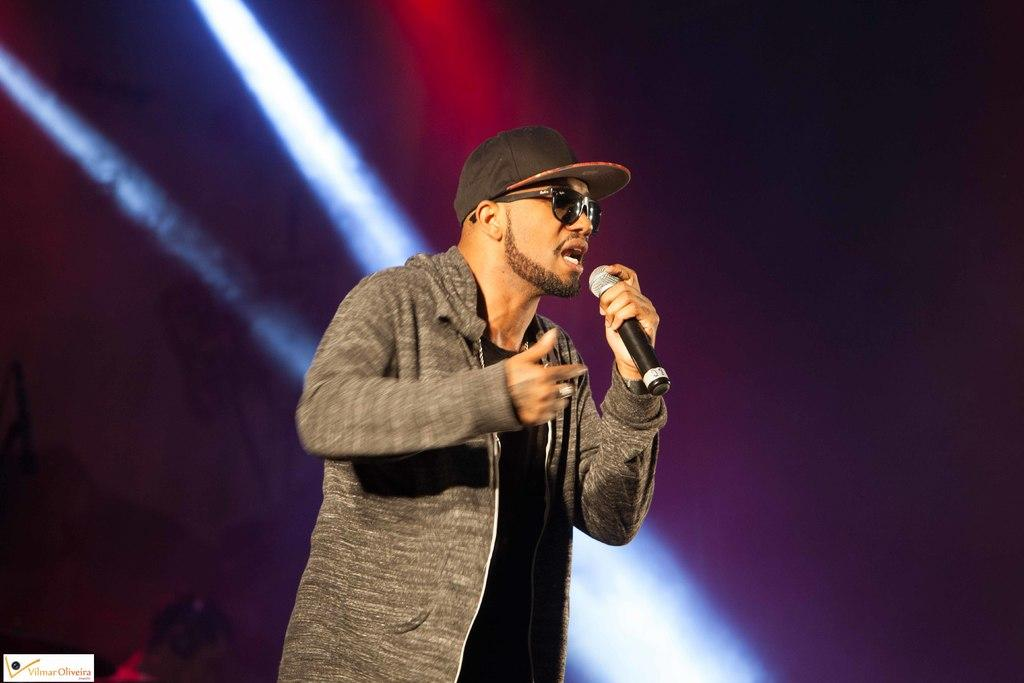Who is the main subject in the image? There is a man in the image. What is the man doing in the image? The man is speaking in the image. How is the man amplifying his voice in the image? The man is using a microphone in the image. What accessories is the man wearing in the image? The man is wearing a cap on his head and sunglasses on his face in the image. What religion does the man's uncle practice in the image? There is no mention of an uncle or religion in the image. 